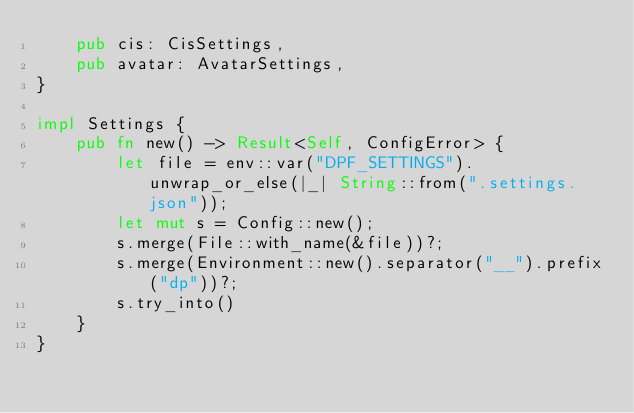Convert code to text. <code><loc_0><loc_0><loc_500><loc_500><_Rust_>    pub cis: CisSettings,
    pub avatar: AvatarSettings,
}

impl Settings {
    pub fn new() -> Result<Self, ConfigError> {
        let file = env::var("DPF_SETTINGS").unwrap_or_else(|_| String::from(".settings.json"));
        let mut s = Config::new();
        s.merge(File::with_name(&file))?;
        s.merge(Environment::new().separator("__").prefix("dp"))?;
        s.try_into()
    }
}
</code> 